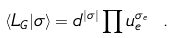Convert formula to latex. <formula><loc_0><loc_0><loc_500><loc_500>\langle L _ { G } | \sigma \rangle = d ^ { | \sigma | } \prod u _ { e } ^ { \sigma _ { e } } \ .</formula> 